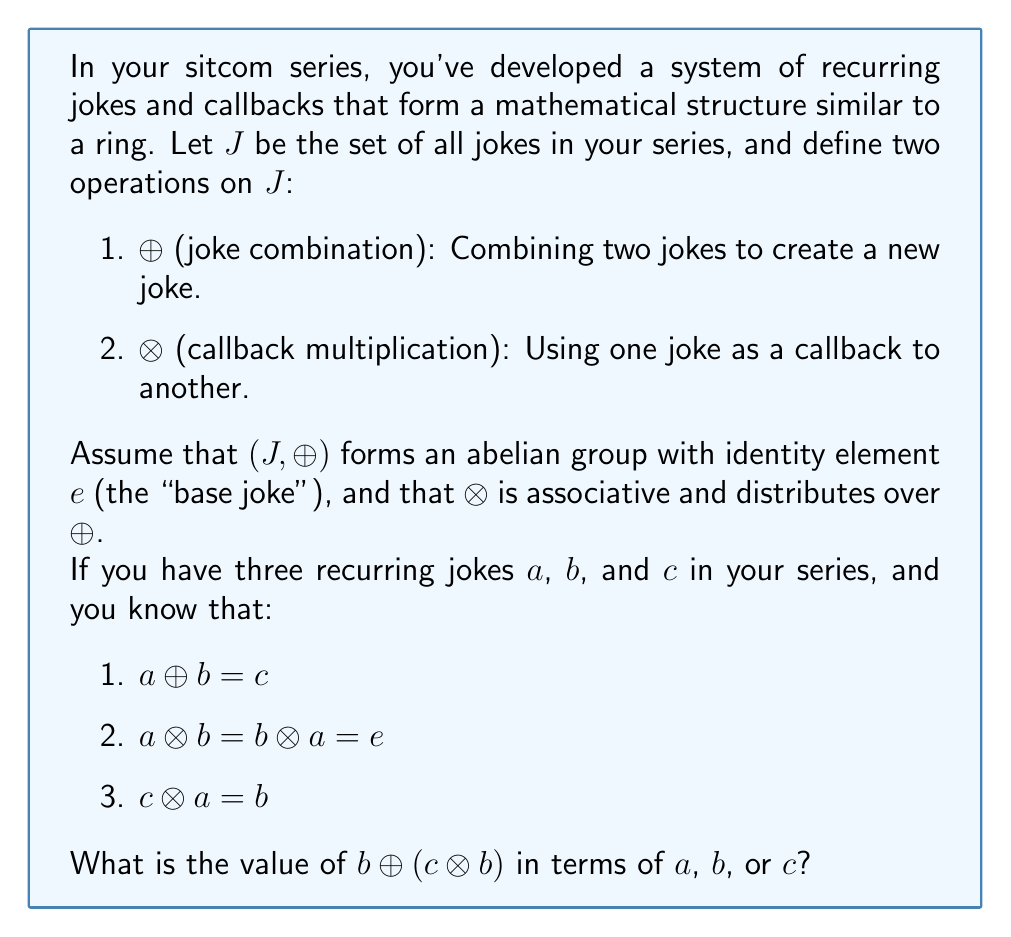Teach me how to tackle this problem. Let's approach this step-by-step using the properties of rings and the given information:

1) First, let's recall the distributive property of rings:
   $x \otimes (y \oplus z) = (x \otimes y) \oplus (x \otimes z)$

2) We're asked to find $b \oplus (c \otimes b)$. Let's focus on $(c \otimes b)$ first.

3) We know that $c = a \oplus b$. Let's substitute this into $(c \otimes b)$:
   $(c \otimes b) = ((a \oplus b) \otimes b)$

4) Now we can use the distributive property:
   $((a \oplus b) \otimes b) = (a \otimes b) \oplus (b \otimes b)$

5) We're given that $a \otimes b = e$, so:
   $(a \otimes b) \oplus (b \otimes b) = e \oplus (b \otimes b)$

6) In any ring, $e \oplus x = x$ for any element $x$, so:
   $e \oplus (b \otimes b) = b \otimes b$

7) Now, let's go back to our original expression:
   $b \oplus (c \otimes b) = b \oplus (b \otimes b)$

8) We're also given that $c \otimes a = b$. Let's substitute $c = a \oplus b$ into this:
   $(a \oplus b) \otimes a = b$

9) Using the distributive property again:
   $(a \otimes a) \oplus (b \otimes a) = b$

10) We know $b \otimes a = e$, so:
    $(a \otimes a) \oplus e = b$

11) Again, $x \oplus e = x$ in any ring, so:
    $a \otimes a = b$

12) Therefore, $b \oplus (c \otimes b) = b \oplus (b \otimes b) = b \oplus (a \otimes a) = b \oplus b$

13) In an abelian group, $x \oplus x = e \oplus x = x$ for any element $x$.

Therefore, $b \oplus (c \otimes b) = b \oplus b = b$.
Answer: $b \oplus (c \otimes b) = b$ 